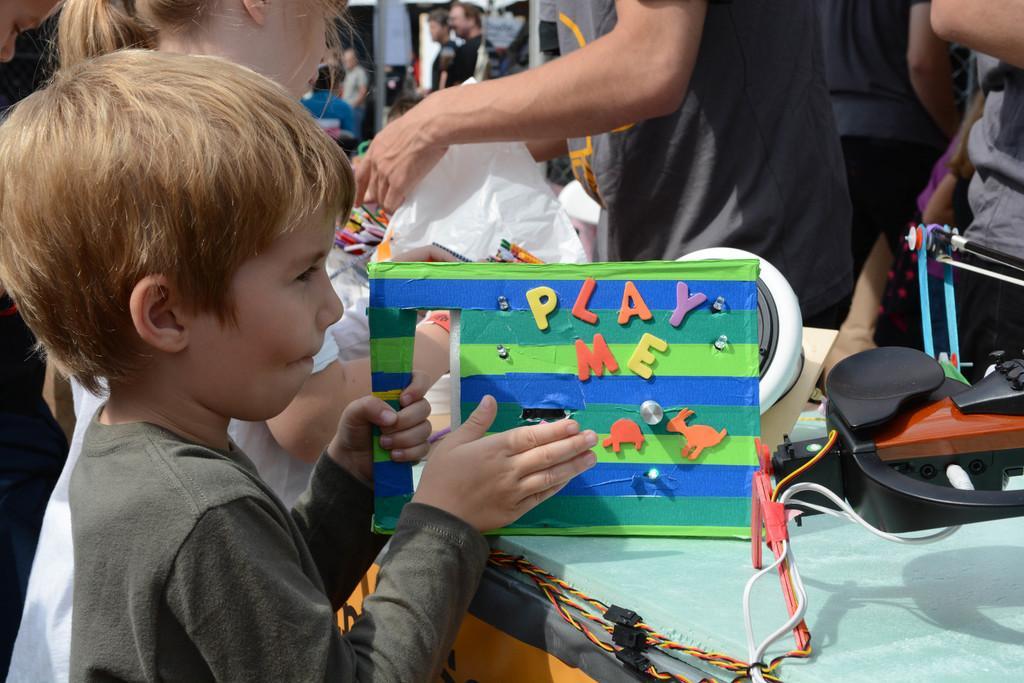Please provide a concise description of this image. In this image we can see a boy holding an object in his hand on which there is some text. In the background of the image there are people. To the right side of the image there is a table on which there are objects, wires. 